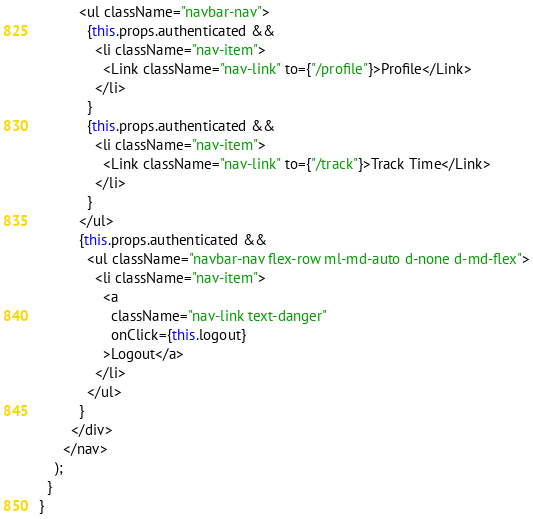<code> <loc_0><loc_0><loc_500><loc_500><_JavaScript_>          <ul className="navbar-nav">
            {this.props.authenticated &&
              <li className="nav-item">
                <Link className="nav-link" to={"/profile"}>Profile</Link>
              </li>
            }
            {this.props.authenticated &&
              <li className="nav-item">
                <Link className="nav-link" to={"/track"}>Track Time</Link>
              </li>
            }
          </ul>
          {this.props.authenticated &&
            <ul className="navbar-nav flex-row ml-md-auto d-none d-md-flex">
              <li className="nav-item">
                <a
                  className="nav-link text-danger"
                  onClick={this.logout}
                >Logout</a>
              </li>
            </ul>
          }
        </div>
      </nav>
    );
  }
}
</code> 